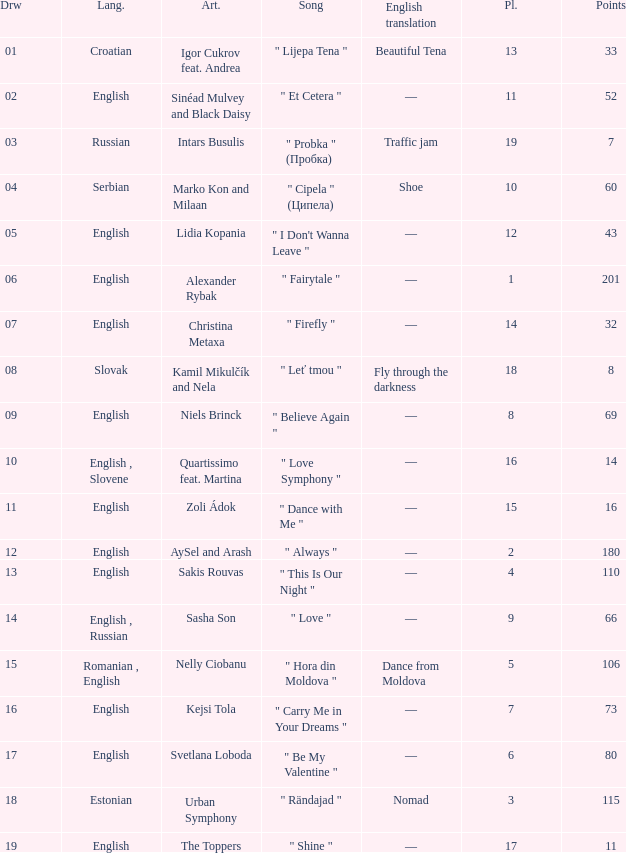What is the average Points when the artist is kamil mikulčík and nela, and the Place is larger than 18? None. 